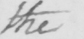Please provide the text content of this handwritten line. the 